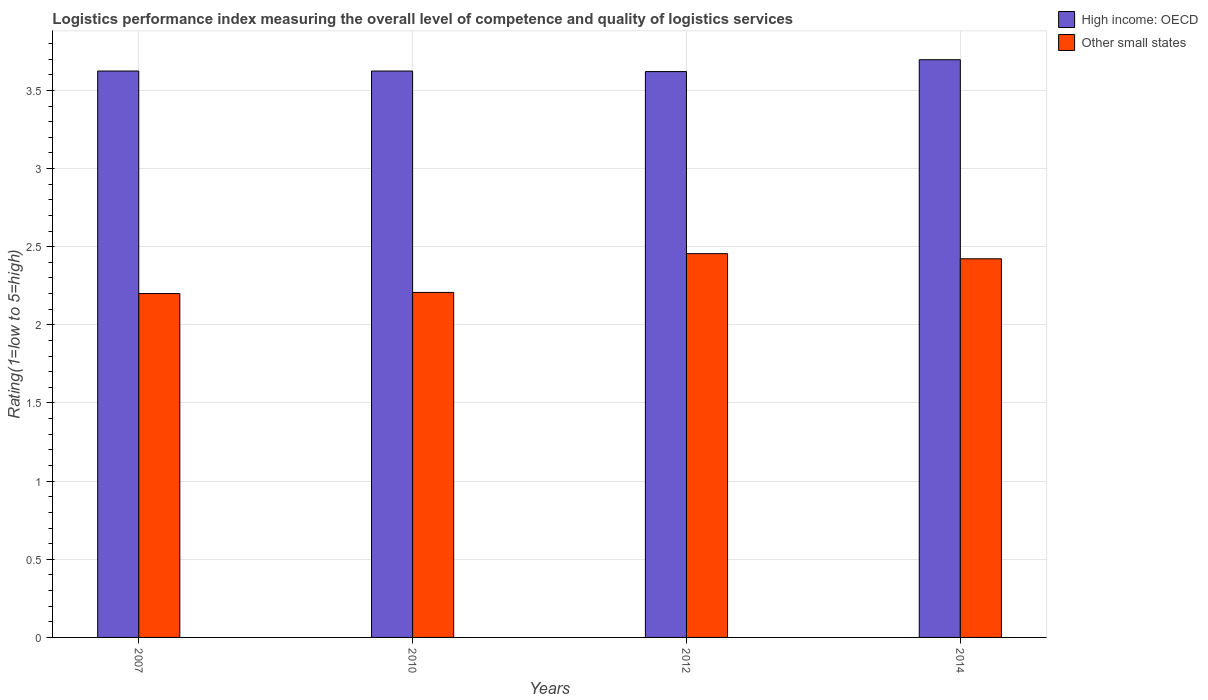How many different coloured bars are there?
Your response must be concise. 2. Are the number of bars per tick equal to the number of legend labels?
Your response must be concise. Yes. Are the number of bars on each tick of the X-axis equal?
Make the answer very short. Yes. How many bars are there on the 4th tick from the right?
Your answer should be compact. 2. What is the label of the 1st group of bars from the left?
Give a very brief answer. 2007. What is the Logistic performance index in High income: OECD in 2012?
Provide a succinct answer. 3.62. Across all years, what is the maximum Logistic performance index in Other small states?
Provide a short and direct response. 2.46. Across all years, what is the minimum Logistic performance index in Other small states?
Your response must be concise. 2.2. In which year was the Logistic performance index in High income: OECD maximum?
Your response must be concise. 2014. In which year was the Logistic performance index in High income: OECD minimum?
Make the answer very short. 2012. What is the total Logistic performance index in High income: OECD in the graph?
Provide a short and direct response. 14.56. What is the difference between the Logistic performance index in Other small states in 2007 and that in 2014?
Offer a terse response. -0.22. What is the difference between the Logistic performance index in High income: OECD in 2010 and the Logistic performance index in Other small states in 2012?
Give a very brief answer. 1.17. What is the average Logistic performance index in Other small states per year?
Your answer should be compact. 2.32. In the year 2010, what is the difference between the Logistic performance index in High income: OECD and Logistic performance index in Other small states?
Provide a short and direct response. 1.42. What is the ratio of the Logistic performance index in Other small states in 2012 to that in 2014?
Provide a succinct answer. 1.01. Is the difference between the Logistic performance index in High income: OECD in 2007 and 2014 greater than the difference between the Logistic performance index in Other small states in 2007 and 2014?
Offer a very short reply. Yes. What is the difference between the highest and the second highest Logistic performance index in Other small states?
Keep it short and to the point. 0.03. What is the difference between the highest and the lowest Logistic performance index in High income: OECD?
Give a very brief answer. 0.08. What does the 1st bar from the left in 2012 represents?
Offer a terse response. High income: OECD. What does the 2nd bar from the right in 2007 represents?
Provide a short and direct response. High income: OECD. How many bars are there?
Give a very brief answer. 8. Are all the bars in the graph horizontal?
Ensure brevity in your answer.  No. What is the difference between two consecutive major ticks on the Y-axis?
Ensure brevity in your answer.  0.5. Are the values on the major ticks of Y-axis written in scientific E-notation?
Your answer should be compact. No. Does the graph contain grids?
Your answer should be compact. Yes. Where does the legend appear in the graph?
Give a very brief answer. Top right. How many legend labels are there?
Your response must be concise. 2. What is the title of the graph?
Provide a short and direct response. Logistics performance index measuring the overall level of competence and quality of logistics services. What is the label or title of the Y-axis?
Provide a short and direct response. Rating(1=low to 5=high). What is the Rating(1=low to 5=high) of High income: OECD in 2007?
Ensure brevity in your answer.  3.62. What is the Rating(1=low to 5=high) of High income: OECD in 2010?
Your answer should be compact. 3.62. What is the Rating(1=low to 5=high) of Other small states in 2010?
Ensure brevity in your answer.  2.21. What is the Rating(1=low to 5=high) in High income: OECD in 2012?
Keep it short and to the point. 3.62. What is the Rating(1=low to 5=high) in Other small states in 2012?
Give a very brief answer. 2.46. What is the Rating(1=low to 5=high) of High income: OECD in 2014?
Your answer should be compact. 3.7. What is the Rating(1=low to 5=high) of Other small states in 2014?
Give a very brief answer. 2.42. Across all years, what is the maximum Rating(1=low to 5=high) of High income: OECD?
Ensure brevity in your answer.  3.7. Across all years, what is the maximum Rating(1=low to 5=high) in Other small states?
Make the answer very short. 2.46. Across all years, what is the minimum Rating(1=low to 5=high) of High income: OECD?
Keep it short and to the point. 3.62. What is the total Rating(1=low to 5=high) in High income: OECD in the graph?
Give a very brief answer. 14.56. What is the total Rating(1=low to 5=high) of Other small states in the graph?
Give a very brief answer. 9.29. What is the difference between the Rating(1=low to 5=high) of Other small states in 2007 and that in 2010?
Provide a succinct answer. -0.01. What is the difference between the Rating(1=low to 5=high) of High income: OECD in 2007 and that in 2012?
Keep it short and to the point. 0. What is the difference between the Rating(1=low to 5=high) of Other small states in 2007 and that in 2012?
Provide a succinct answer. -0.26. What is the difference between the Rating(1=low to 5=high) of High income: OECD in 2007 and that in 2014?
Offer a terse response. -0.07. What is the difference between the Rating(1=low to 5=high) in Other small states in 2007 and that in 2014?
Ensure brevity in your answer.  -0.22. What is the difference between the Rating(1=low to 5=high) of High income: OECD in 2010 and that in 2012?
Your response must be concise. 0. What is the difference between the Rating(1=low to 5=high) in Other small states in 2010 and that in 2012?
Your response must be concise. -0.25. What is the difference between the Rating(1=low to 5=high) of High income: OECD in 2010 and that in 2014?
Ensure brevity in your answer.  -0.07. What is the difference between the Rating(1=low to 5=high) of Other small states in 2010 and that in 2014?
Make the answer very short. -0.22. What is the difference between the Rating(1=low to 5=high) of High income: OECD in 2012 and that in 2014?
Offer a terse response. -0.08. What is the difference between the Rating(1=low to 5=high) in Other small states in 2012 and that in 2014?
Ensure brevity in your answer.  0.03. What is the difference between the Rating(1=low to 5=high) of High income: OECD in 2007 and the Rating(1=low to 5=high) of Other small states in 2010?
Provide a succinct answer. 1.42. What is the difference between the Rating(1=low to 5=high) of High income: OECD in 2007 and the Rating(1=low to 5=high) of Other small states in 2012?
Your response must be concise. 1.17. What is the difference between the Rating(1=low to 5=high) in High income: OECD in 2007 and the Rating(1=low to 5=high) in Other small states in 2014?
Ensure brevity in your answer.  1.2. What is the difference between the Rating(1=low to 5=high) in High income: OECD in 2010 and the Rating(1=low to 5=high) in Other small states in 2012?
Give a very brief answer. 1.17. What is the difference between the Rating(1=low to 5=high) of High income: OECD in 2010 and the Rating(1=low to 5=high) of Other small states in 2014?
Your response must be concise. 1.2. What is the difference between the Rating(1=low to 5=high) in High income: OECD in 2012 and the Rating(1=low to 5=high) in Other small states in 2014?
Keep it short and to the point. 1.2. What is the average Rating(1=low to 5=high) of High income: OECD per year?
Your answer should be very brief. 3.64. What is the average Rating(1=low to 5=high) of Other small states per year?
Give a very brief answer. 2.32. In the year 2007, what is the difference between the Rating(1=low to 5=high) of High income: OECD and Rating(1=low to 5=high) of Other small states?
Offer a very short reply. 1.42. In the year 2010, what is the difference between the Rating(1=low to 5=high) of High income: OECD and Rating(1=low to 5=high) of Other small states?
Your answer should be very brief. 1.42. In the year 2012, what is the difference between the Rating(1=low to 5=high) of High income: OECD and Rating(1=low to 5=high) of Other small states?
Offer a terse response. 1.16. In the year 2014, what is the difference between the Rating(1=low to 5=high) of High income: OECD and Rating(1=low to 5=high) of Other small states?
Your answer should be compact. 1.27. What is the ratio of the Rating(1=low to 5=high) of Other small states in 2007 to that in 2012?
Keep it short and to the point. 0.9. What is the ratio of the Rating(1=low to 5=high) in High income: OECD in 2007 to that in 2014?
Keep it short and to the point. 0.98. What is the ratio of the Rating(1=low to 5=high) in Other small states in 2007 to that in 2014?
Keep it short and to the point. 0.91. What is the ratio of the Rating(1=low to 5=high) of Other small states in 2010 to that in 2012?
Ensure brevity in your answer.  0.9. What is the ratio of the Rating(1=low to 5=high) of High income: OECD in 2010 to that in 2014?
Your answer should be very brief. 0.98. What is the ratio of the Rating(1=low to 5=high) in Other small states in 2010 to that in 2014?
Offer a terse response. 0.91. What is the ratio of the Rating(1=low to 5=high) of High income: OECD in 2012 to that in 2014?
Your answer should be very brief. 0.98. What is the ratio of the Rating(1=low to 5=high) in Other small states in 2012 to that in 2014?
Provide a succinct answer. 1.01. What is the difference between the highest and the second highest Rating(1=low to 5=high) in High income: OECD?
Give a very brief answer. 0.07. What is the difference between the highest and the second highest Rating(1=low to 5=high) in Other small states?
Your answer should be very brief. 0.03. What is the difference between the highest and the lowest Rating(1=low to 5=high) in High income: OECD?
Your answer should be very brief. 0.08. What is the difference between the highest and the lowest Rating(1=low to 5=high) of Other small states?
Ensure brevity in your answer.  0.26. 